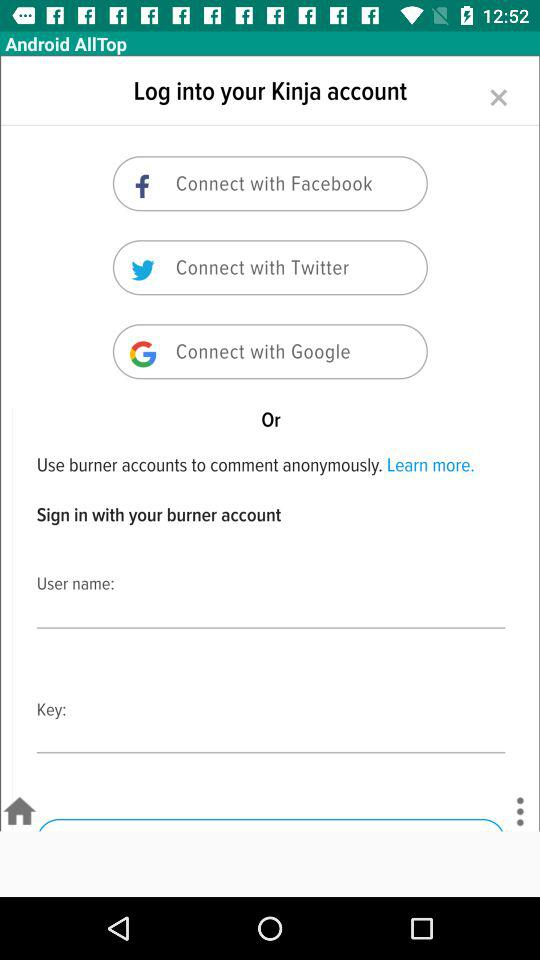Which applications can be used for connecting? The applications that can be used for connecting are "Facebook", "Twitter" and "Google". 